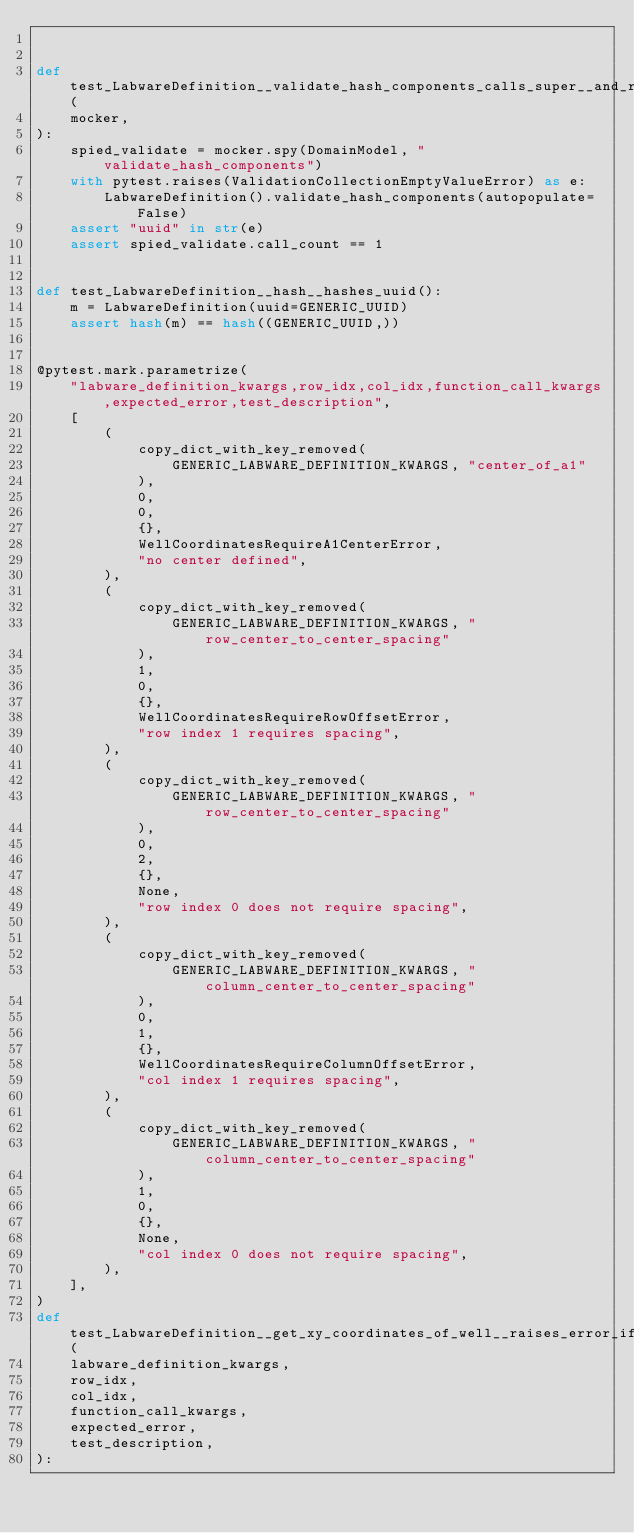<code> <loc_0><loc_0><loc_500><loc_500><_Python_>

def test_LabwareDefinition__validate_hash_components_calls_super__and_raises_error_if_invalid_id(
    mocker,
):
    spied_validate = mocker.spy(DomainModel, "validate_hash_components")
    with pytest.raises(ValidationCollectionEmptyValueError) as e:
        LabwareDefinition().validate_hash_components(autopopulate=False)
    assert "uuid" in str(e)
    assert spied_validate.call_count == 1


def test_LabwareDefinition__hash__hashes_uuid():
    m = LabwareDefinition(uuid=GENERIC_UUID)
    assert hash(m) == hash((GENERIC_UUID,))


@pytest.mark.parametrize(
    "labware_definition_kwargs,row_idx,col_idx,function_call_kwargs,expected_error,test_description",
    [
        (
            copy_dict_with_key_removed(
                GENERIC_LABWARE_DEFINITION_KWARGS, "center_of_a1"
            ),
            0,
            0,
            {},
            WellCoordinatesRequireA1CenterError,
            "no center defined",
        ),
        (
            copy_dict_with_key_removed(
                GENERIC_LABWARE_DEFINITION_KWARGS, "row_center_to_center_spacing"
            ),
            1,
            0,
            {},
            WellCoordinatesRequireRowOffsetError,
            "row index 1 requires spacing",
        ),
        (
            copy_dict_with_key_removed(
                GENERIC_LABWARE_DEFINITION_KWARGS, "row_center_to_center_spacing"
            ),
            0,
            2,
            {},
            None,
            "row index 0 does not require spacing",
        ),
        (
            copy_dict_with_key_removed(
                GENERIC_LABWARE_DEFINITION_KWARGS, "column_center_to_center_spacing"
            ),
            0,
            1,
            {},
            WellCoordinatesRequireColumnOffsetError,
            "col index 1 requires spacing",
        ),
        (
            copy_dict_with_key_removed(
                GENERIC_LABWARE_DEFINITION_KWARGS, "column_center_to_center_spacing"
            ),
            1,
            0,
            {},
            None,
            "col index 0 does not require spacing",
        ),
    ],
)
def test_LabwareDefinition__get_xy_coordinates_of_well__raises_error_if_definitions_missing(
    labware_definition_kwargs,
    row_idx,
    col_idx,
    function_call_kwargs,
    expected_error,
    test_description,
):</code> 